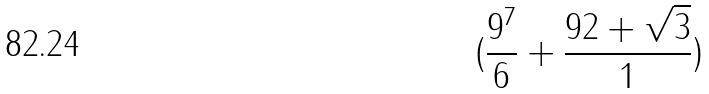<formula> <loc_0><loc_0><loc_500><loc_500>( \frac { 9 ^ { 7 } } { 6 } + \frac { 9 2 + \sqrt { 3 } } { 1 } )</formula> 